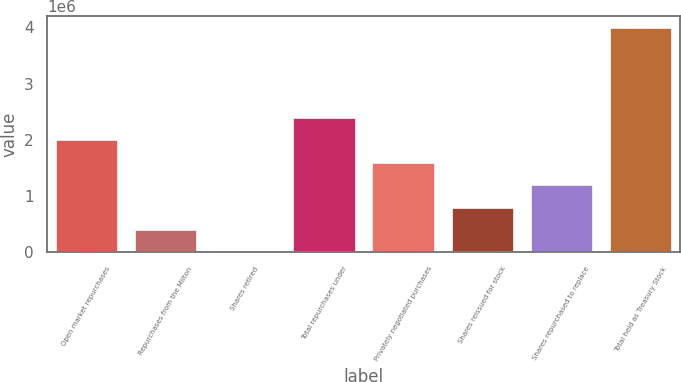Convert chart to OTSL. <chart><loc_0><loc_0><loc_500><loc_500><bar_chart><fcel>Open market repurchases<fcel>Repurchases from the Milton<fcel>Shares retired<fcel>Total repurchases under<fcel>Privately negotiated purchases<fcel>Shares reissued for stock<fcel>Shares repurchased to replace<fcel>Total held as Treasury Stock<nl><fcel>2.00719e+06<fcel>411694<fcel>12820<fcel>2.40607e+06<fcel>1.60832e+06<fcel>810568<fcel>1.20944e+06<fcel>4.00156e+06<nl></chart> 